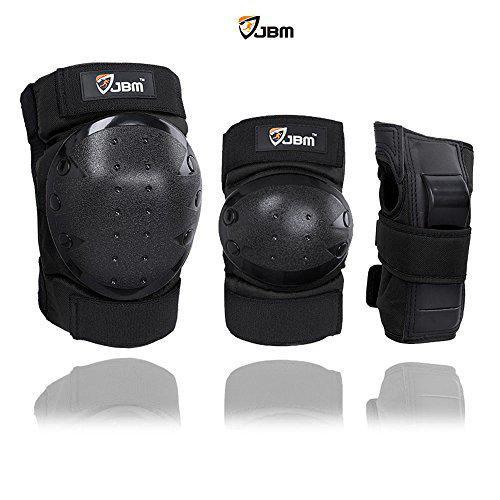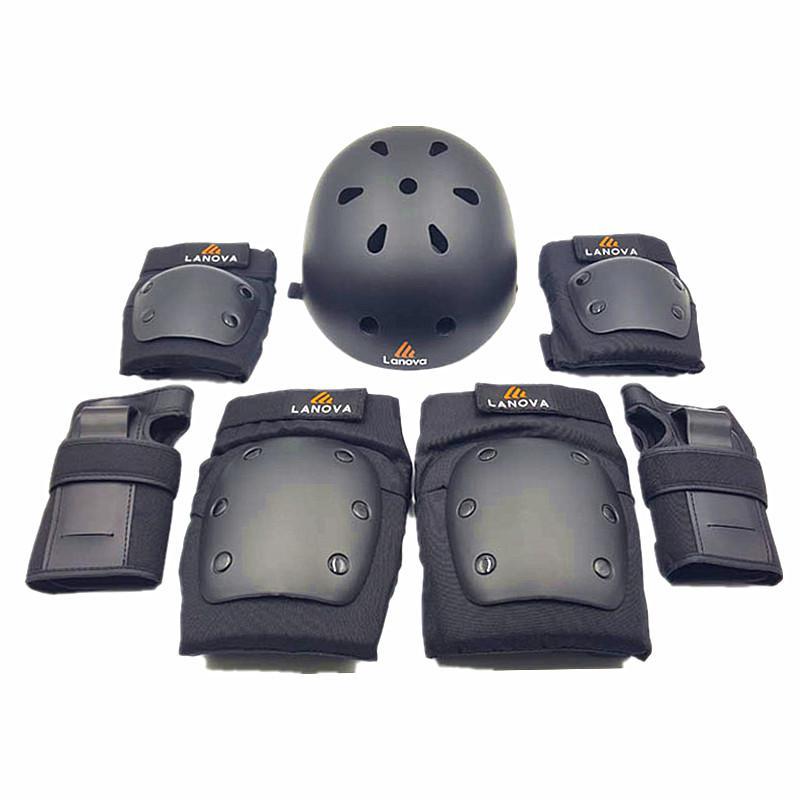The first image is the image on the left, the second image is the image on the right. Evaluate the accuracy of this statement regarding the images: "An image shows a line of three protective gear items, featuring round perforated pads for the knee and elbow.". Is it true? Answer yes or no. Yes. The first image is the image on the left, the second image is the image on the right. Considering the images on both sides, is "There are no more than five knee braces." valid? Answer yes or no. No. 